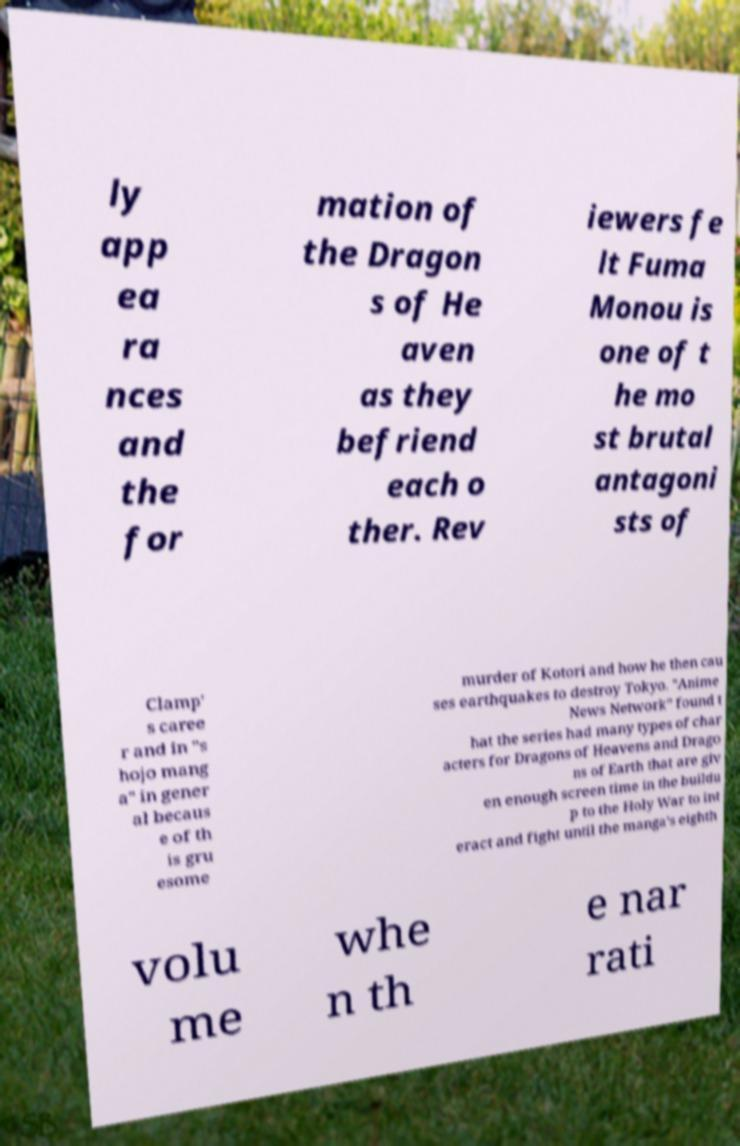There's text embedded in this image that I need extracted. Can you transcribe it verbatim? ly app ea ra nces and the for mation of the Dragon s of He aven as they befriend each o ther. Rev iewers fe lt Fuma Monou is one of t he mo st brutal antagoni sts of Clamp' s caree r and in "s hojo mang a" in gener al becaus e of th is gru esome murder of Kotori and how he then cau ses earthquakes to destroy Tokyo. "Anime News Network" found t hat the series had many types of char acters for Dragons of Heavens and Drago ns of Earth that are giv en enough screen time in the buildu p to the Holy War to int eract and fight until the manga's eighth volu me whe n th e nar rati 